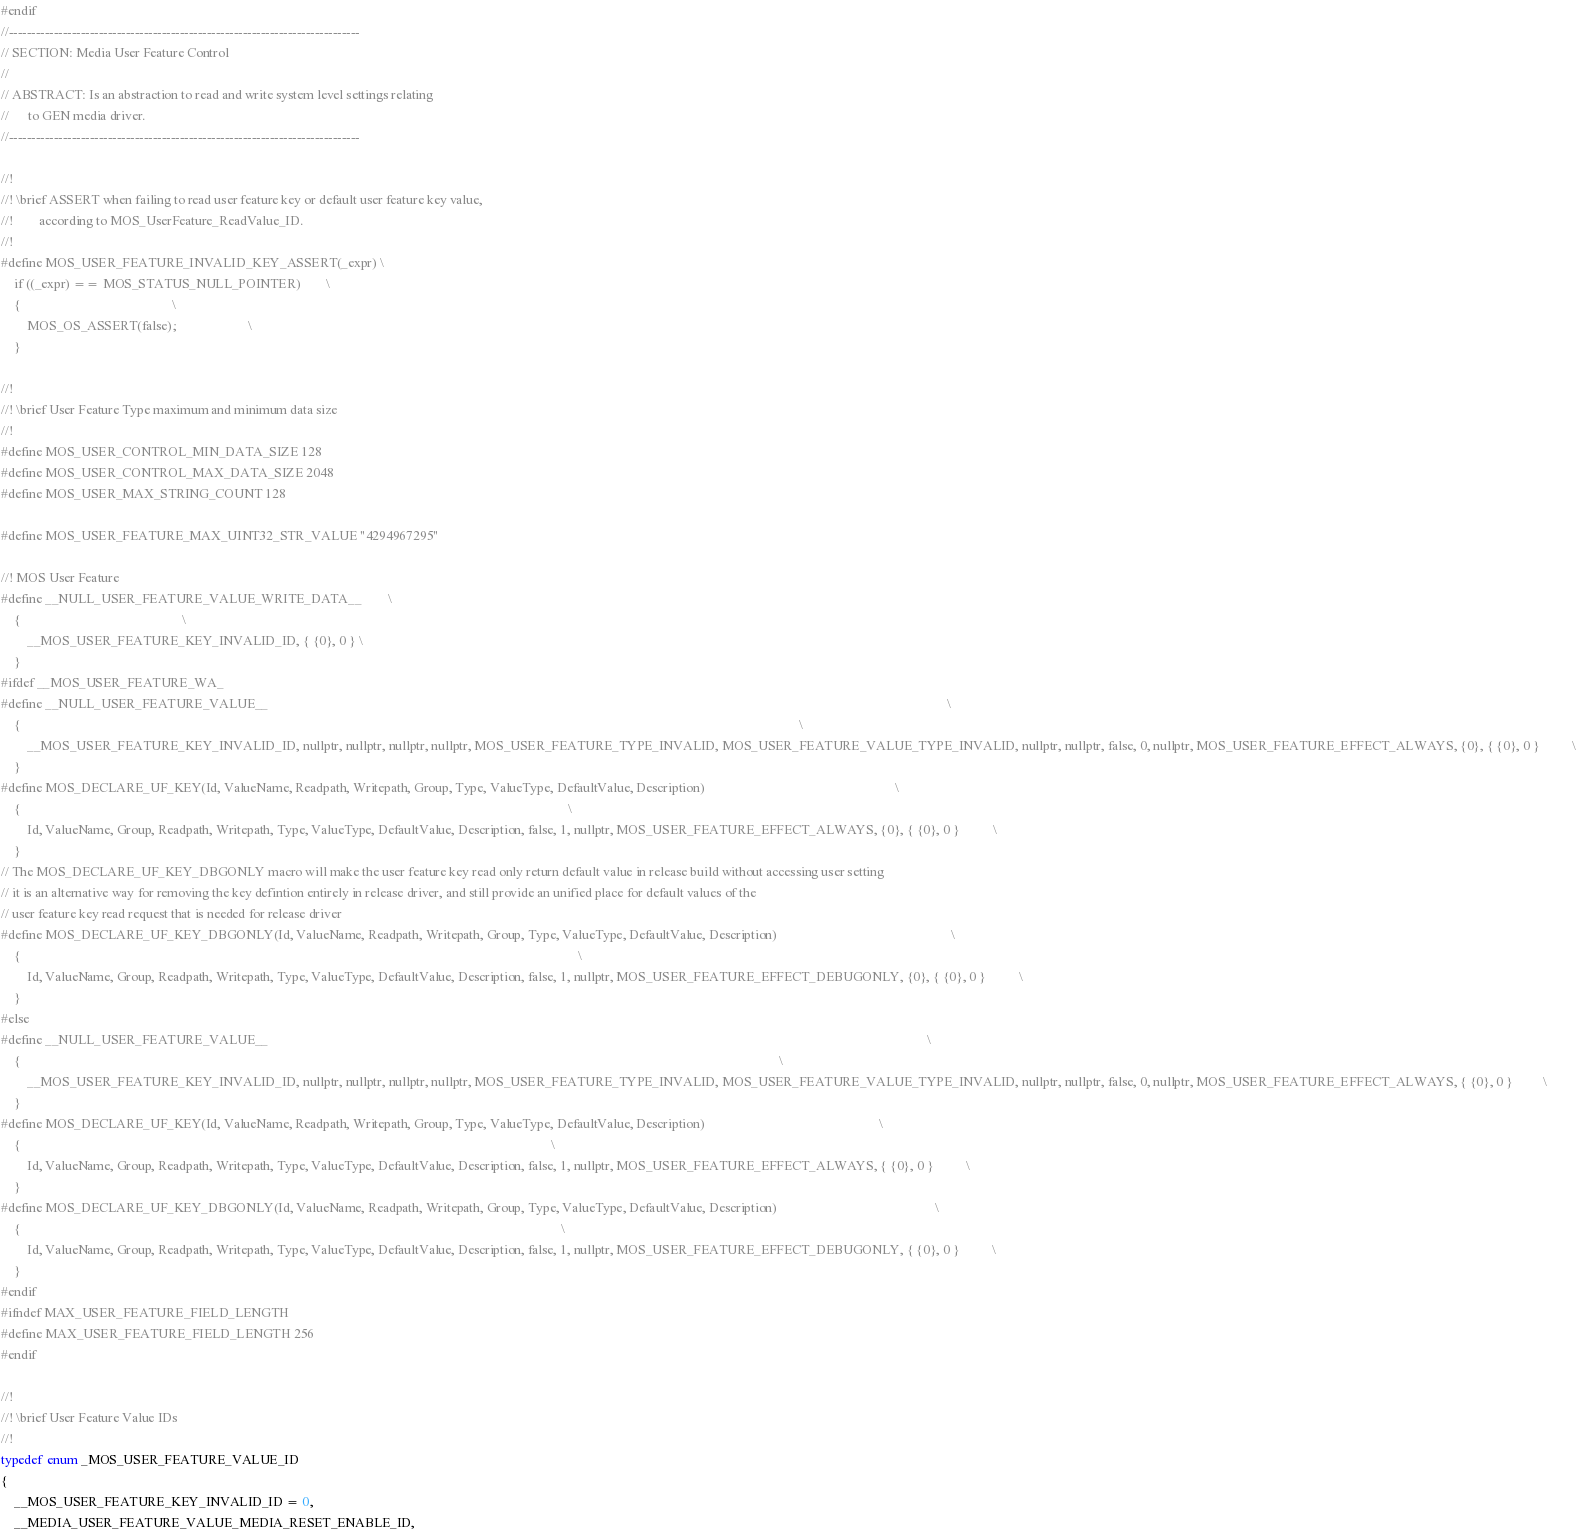Convert code to text. <code><loc_0><loc_0><loc_500><loc_500><_C_>#endif
//------------------------------------------------------------------------------
// SECTION: Media User Feature Control
//
// ABSTRACT: Is an abstraction to read and write system level settings relating
//      to GEN media driver.
//------------------------------------------------------------------------------

//!
//! \brief ASSERT when failing to read user feature key or default user feature key value,
//!        according to MOS_UserFeature_ReadValue_ID.
//!
#define MOS_USER_FEATURE_INVALID_KEY_ASSERT(_expr) \
    if ((_expr) == MOS_STATUS_NULL_POINTER)        \
    {                                              \
        MOS_OS_ASSERT(false);                      \
    }

//!
//! \brief User Feature Type maximum and minimum data size
//!
#define MOS_USER_CONTROL_MIN_DATA_SIZE 128
#define MOS_USER_CONTROL_MAX_DATA_SIZE 2048
#define MOS_USER_MAX_STRING_COUNT 128

#define MOS_USER_FEATURE_MAX_UINT32_STR_VALUE "4294967295"

//! MOS User Feature
#define __NULL_USER_FEATURE_VALUE_WRITE_DATA__        \
    {                                                 \
        __MOS_USER_FEATURE_KEY_INVALID_ID, { {0}, 0 } \
    }
#ifdef __MOS_USER_FEATURE_WA_
#define __NULL_USER_FEATURE_VALUE__                                                                                                                                                                                                              \
    {                                                                                                                                                                                                                                            \
        __MOS_USER_FEATURE_KEY_INVALID_ID, nullptr, nullptr, nullptr, nullptr, MOS_USER_FEATURE_TYPE_INVALID, MOS_USER_FEATURE_VALUE_TYPE_INVALID, nullptr, nullptr, false, 0, nullptr, MOS_USER_FEATURE_EFFECT_ALWAYS, {0}, { {0}, 0 }          \
    }
#define MOS_DECLARE_UF_KEY(Id, ValueName, Readpath, Writepath, Group, Type, ValueType, DefaultValue, Description)                                                          \
    {                                                                                                                                                                      \
        Id, ValueName, Group, Readpath, Writepath, Type, ValueType, DefaultValue, Description, false, 1, nullptr, MOS_USER_FEATURE_EFFECT_ALWAYS, {0}, { {0}, 0 }          \
    }
// The MOS_DECLARE_UF_KEY_DBGONLY macro will make the user feature key read only return default value in release build without accessing user setting
// it is an alternative way for removing the key defintion entirely in release driver, and still provide an unified place for default values of the
// user feature key read request that is needed for release driver
#define MOS_DECLARE_UF_KEY_DBGONLY(Id, ValueName, Readpath, Writepath, Group, Type, ValueType, DefaultValue, Description)                                                     \
    {                                                                                                                                                                         \
        Id, ValueName, Group, Readpath, Writepath, Type, ValueType, DefaultValue, Description, false, 1, nullptr, MOS_USER_FEATURE_EFFECT_DEBUGONLY, {0}, { {0}, 0 }          \
    }
#else
#define __NULL_USER_FEATURE_VALUE__                                                                                                                                                                                                        \
    {                                                                                                                                                                                                                                      \
        __MOS_USER_FEATURE_KEY_INVALID_ID, nullptr, nullptr, nullptr, nullptr, MOS_USER_FEATURE_TYPE_INVALID, MOS_USER_FEATURE_VALUE_TYPE_INVALID, nullptr, nullptr, false, 0, nullptr, MOS_USER_FEATURE_EFFECT_ALWAYS, { {0}, 0 }         \
    }
#define MOS_DECLARE_UF_KEY(Id, ValueName, Readpath, Writepath, Group, Type, ValueType, DefaultValue, Description)                                                     \
    {                                                                                                                                                                 \
        Id, ValueName, Group, Readpath, Writepath, Type, ValueType, DefaultValue, Description, false, 1, nullptr, MOS_USER_FEATURE_EFFECT_ALWAYS, { {0}, 0 }          \
    }
#define MOS_DECLARE_UF_KEY_DBGONLY(Id, ValueName, Readpath, Writepath, Group, Type, ValueType, DefaultValue, Description)                                                \
    {                                                                                                                                                                    \
        Id, ValueName, Group, Readpath, Writepath, Type, ValueType, DefaultValue, Description, false, 1, nullptr, MOS_USER_FEATURE_EFFECT_DEBUGONLY, { {0}, 0 }          \
    }
#endif
#ifndef MAX_USER_FEATURE_FIELD_LENGTH
#define MAX_USER_FEATURE_FIELD_LENGTH 256
#endif

//!
//! \brief User Feature Value IDs
//!
typedef enum _MOS_USER_FEATURE_VALUE_ID
{
    __MOS_USER_FEATURE_KEY_INVALID_ID = 0,
    __MEDIA_USER_FEATURE_VALUE_MEDIA_RESET_ENABLE_ID,</code> 